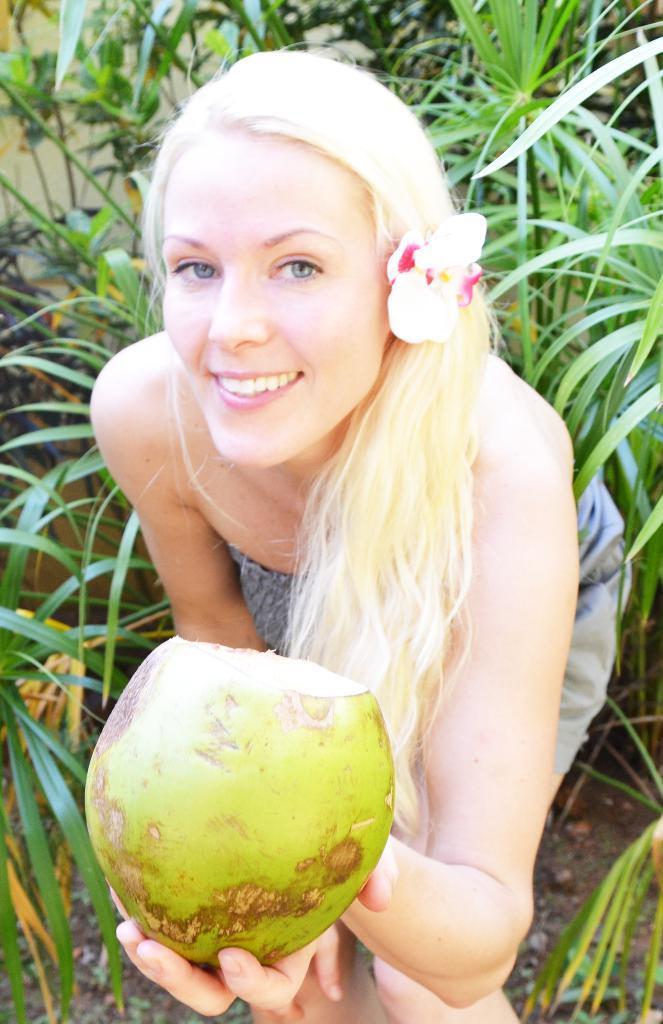In one or two sentences, can you explain what this image depicts? In this picture there is a girl in the center of the image, by holding a coconut in her hand and there is greenery around the area of the image. 